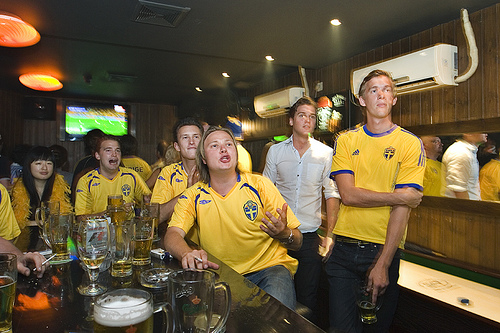<image>
Can you confirm if the beer is under the shirt? No. The beer is not positioned under the shirt. The vertical relationship between these objects is different. Is there a tv behind the man? Yes. From this viewpoint, the tv is positioned behind the man, with the man partially or fully occluding the tv. Is the girl in front of the glass? No. The girl is not in front of the glass. The spatial positioning shows a different relationship between these objects. 